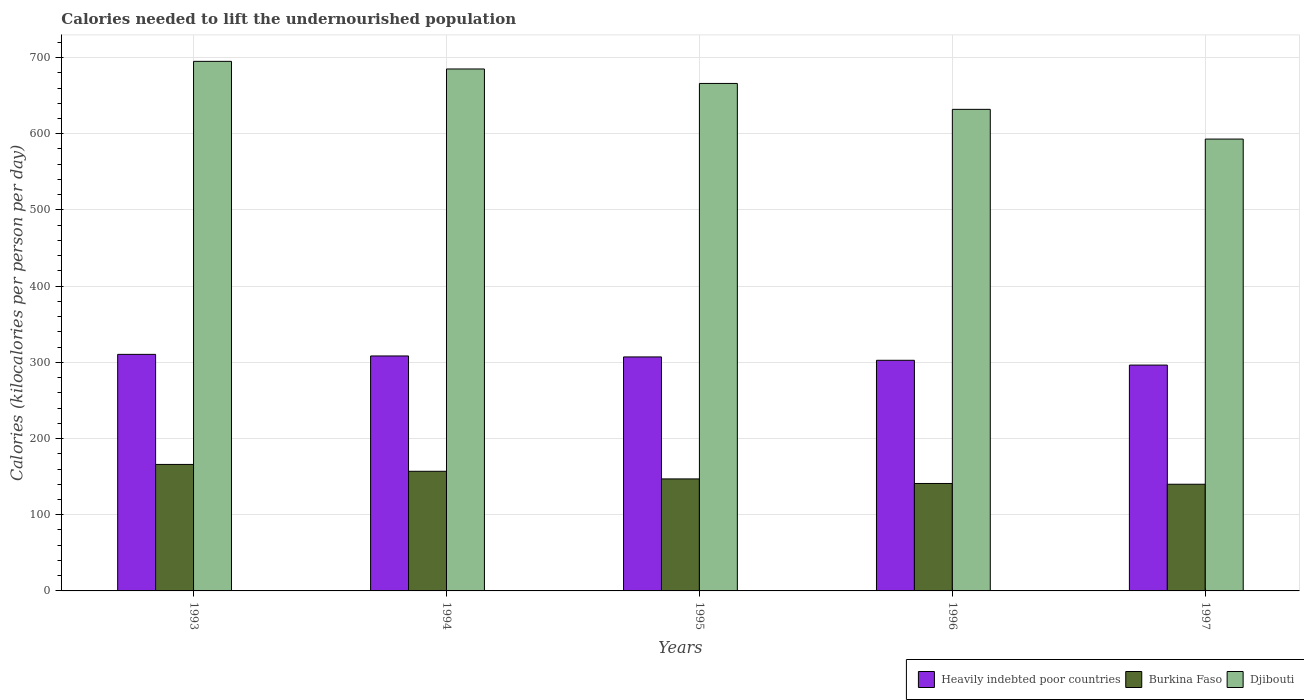How many different coloured bars are there?
Offer a terse response. 3. How many groups of bars are there?
Provide a short and direct response. 5. Are the number of bars per tick equal to the number of legend labels?
Your response must be concise. Yes. Are the number of bars on each tick of the X-axis equal?
Make the answer very short. Yes. How many bars are there on the 4th tick from the left?
Give a very brief answer. 3. How many bars are there on the 1st tick from the right?
Provide a short and direct response. 3. In how many cases, is the number of bars for a given year not equal to the number of legend labels?
Provide a succinct answer. 0. What is the total calories needed to lift the undernourished population in Djibouti in 1996?
Make the answer very short. 632. Across all years, what is the maximum total calories needed to lift the undernourished population in Burkina Faso?
Keep it short and to the point. 166. Across all years, what is the minimum total calories needed to lift the undernourished population in Burkina Faso?
Your answer should be compact. 140. In which year was the total calories needed to lift the undernourished population in Heavily indebted poor countries minimum?
Provide a short and direct response. 1997. What is the total total calories needed to lift the undernourished population in Djibouti in the graph?
Keep it short and to the point. 3271. What is the difference between the total calories needed to lift the undernourished population in Burkina Faso in 1993 and that in 1997?
Offer a terse response. 26. What is the difference between the total calories needed to lift the undernourished population in Burkina Faso in 1997 and the total calories needed to lift the undernourished population in Heavily indebted poor countries in 1994?
Provide a short and direct response. -168.37. What is the average total calories needed to lift the undernourished population in Heavily indebted poor countries per year?
Your response must be concise. 305. In the year 1994, what is the difference between the total calories needed to lift the undernourished population in Djibouti and total calories needed to lift the undernourished population in Heavily indebted poor countries?
Your response must be concise. 376.63. What is the ratio of the total calories needed to lift the undernourished population in Burkina Faso in 1996 to that in 1997?
Offer a very short reply. 1.01. Is the difference between the total calories needed to lift the undernourished population in Djibouti in 1995 and 1997 greater than the difference between the total calories needed to lift the undernourished population in Heavily indebted poor countries in 1995 and 1997?
Keep it short and to the point. Yes. What is the difference between the highest and the second highest total calories needed to lift the undernourished population in Burkina Faso?
Offer a very short reply. 9. What is the difference between the highest and the lowest total calories needed to lift the undernourished population in Burkina Faso?
Offer a very short reply. 26. In how many years, is the total calories needed to lift the undernourished population in Djibouti greater than the average total calories needed to lift the undernourished population in Djibouti taken over all years?
Ensure brevity in your answer.  3. Is the sum of the total calories needed to lift the undernourished population in Djibouti in 1994 and 1997 greater than the maximum total calories needed to lift the undernourished population in Heavily indebted poor countries across all years?
Provide a succinct answer. Yes. What does the 3rd bar from the left in 1996 represents?
Your answer should be compact. Djibouti. What does the 1st bar from the right in 1995 represents?
Provide a short and direct response. Djibouti. Is it the case that in every year, the sum of the total calories needed to lift the undernourished population in Heavily indebted poor countries and total calories needed to lift the undernourished population in Djibouti is greater than the total calories needed to lift the undernourished population in Burkina Faso?
Give a very brief answer. Yes. How many bars are there?
Ensure brevity in your answer.  15. Are all the bars in the graph horizontal?
Keep it short and to the point. No. What is the difference between two consecutive major ticks on the Y-axis?
Provide a short and direct response. 100. What is the title of the graph?
Make the answer very short. Calories needed to lift the undernourished population. What is the label or title of the Y-axis?
Your answer should be compact. Calories (kilocalories per person per day). What is the Calories (kilocalories per person per day) in Heavily indebted poor countries in 1993?
Your response must be concise. 310.45. What is the Calories (kilocalories per person per day) in Burkina Faso in 1993?
Provide a short and direct response. 166. What is the Calories (kilocalories per person per day) in Djibouti in 1993?
Your response must be concise. 695. What is the Calories (kilocalories per person per day) of Heavily indebted poor countries in 1994?
Provide a succinct answer. 308.37. What is the Calories (kilocalories per person per day) of Burkina Faso in 1994?
Your answer should be very brief. 157. What is the Calories (kilocalories per person per day) of Djibouti in 1994?
Provide a short and direct response. 685. What is the Calories (kilocalories per person per day) of Heavily indebted poor countries in 1995?
Provide a succinct answer. 307.09. What is the Calories (kilocalories per person per day) in Burkina Faso in 1995?
Offer a terse response. 147. What is the Calories (kilocalories per person per day) of Djibouti in 1995?
Offer a terse response. 666. What is the Calories (kilocalories per person per day) in Heavily indebted poor countries in 1996?
Make the answer very short. 302.69. What is the Calories (kilocalories per person per day) in Burkina Faso in 1996?
Give a very brief answer. 141. What is the Calories (kilocalories per person per day) in Djibouti in 1996?
Your response must be concise. 632. What is the Calories (kilocalories per person per day) in Heavily indebted poor countries in 1997?
Your answer should be compact. 296.39. What is the Calories (kilocalories per person per day) in Burkina Faso in 1997?
Ensure brevity in your answer.  140. What is the Calories (kilocalories per person per day) of Djibouti in 1997?
Make the answer very short. 593. Across all years, what is the maximum Calories (kilocalories per person per day) of Heavily indebted poor countries?
Your answer should be compact. 310.45. Across all years, what is the maximum Calories (kilocalories per person per day) in Burkina Faso?
Make the answer very short. 166. Across all years, what is the maximum Calories (kilocalories per person per day) of Djibouti?
Your answer should be very brief. 695. Across all years, what is the minimum Calories (kilocalories per person per day) in Heavily indebted poor countries?
Your answer should be very brief. 296.39. Across all years, what is the minimum Calories (kilocalories per person per day) in Burkina Faso?
Make the answer very short. 140. Across all years, what is the minimum Calories (kilocalories per person per day) in Djibouti?
Ensure brevity in your answer.  593. What is the total Calories (kilocalories per person per day) of Heavily indebted poor countries in the graph?
Provide a short and direct response. 1524.99. What is the total Calories (kilocalories per person per day) in Burkina Faso in the graph?
Your answer should be compact. 751. What is the total Calories (kilocalories per person per day) of Djibouti in the graph?
Offer a very short reply. 3271. What is the difference between the Calories (kilocalories per person per day) in Heavily indebted poor countries in 1993 and that in 1994?
Ensure brevity in your answer.  2.08. What is the difference between the Calories (kilocalories per person per day) of Djibouti in 1993 and that in 1994?
Your response must be concise. 10. What is the difference between the Calories (kilocalories per person per day) of Heavily indebted poor countries in 1993 and that in 1995?
Your response must be concise. 3.35. What is the difference between the Calories (kilocalories per person per day) of Djibouti in 1993 and that in 1995?
Give a very brief answer. 29. What is the difference between the Calories (kilocalories per person per day) in Heavily indebted poor countries in 1993 and that in 1996?
Ensure brevity in your answer.  7.76. What is the difference between the Calories (kilocalories per person per day) of Djibouti in 1993 and that in 1996?
Keep it short and to the point. 63. What is the difference between the Calories (kilocalories per person per day) of Heavily indebted poor countries in 1993 and that in 1997?
Provide a succinct answer. 14.05. What is the difference between the Calories (kilocalories per person per day) of Burkina Faso in 1993 and that in 1997?
Make the answer very short. 26. What is the difference between the Calories (kilocalories per person per day) of Djibouti in 1993 and that in 1997?
Make the answer very short. 102. What is the difference between the Calories (kilocalories per person per day) of Heavily indebted poor countries in 1994 and that in 1995?
Offer a terse response. 1.28. What is the difference between the Calories (kilocalories per person per day) of Burkina Faso in 1994 and that in 1995?
Your answer should be very brief. 10. What is the difference between the Calories (kilocalories per person per day) in Heavily indebted poor countries in 1994 and that in 1996?
Make the answer very short. 5.68. What is the difference between the Calories (kilocalories per person per day) of Heavily indebted poor countries in 1994 and that in 1997?
Offer a terse response. 11.98. What is the difference between the Calories (kilocalories per person per day) of Djibouti in 1994 and that in 1997?
Keep it short and to the point. 92. What is the difference between the Calories (kilocalories per person per day) of Heavily indebted poor countries in 1995 and that in 1996?
Offer a very short reply. 4.4. What is the difference between the Calories (kilocalories per person per day) in Djibouti in 1995 and that in 1996?
Your answer should be compact. 34. What is the difference between the Calories (kilocalories per person per day) of Heavily indebted poor countries in 1995 and that in 1997?
Offer a terse response. 10.7. What is the difference between the Calories (kilocalories per person per day) of Djibouti in 1995 and that in 1997?
Your answer should be compact. 73. What is the difference between the Calories (kilocalories per person per day) in Heavily indebted poor countries in 1996 and that in 1997?
Make the answer very short. 6.3. What is the difference between the Calories (kilocalories per person per day) in Burkina Faso in 1996 and that in 1997?
Make the answer very short. 1. What is the difference between the Calories (kilocalories per person per day) of Djibouti in 1996 and that in 1997?
Offer a very short reply. 39. What is the difference between the Calories (kilocalories per person per day) in Heavily indebted poor countries in 1993 and the Calories (kilocalories per person per day) in Burkina Faso in 1994?
Your answer should be very brief. 153.45. What is the difference between the Calories (kilocalories per person per day) in Heavily indebted poor countries in 1993 and the Calories (kilocalories per person per day) in Djibouti in 1994?
Give a very brief answer. -374.55. What is the difference between the Calories (kilocalories per person per day) in Burkina Faso in 1993 and the Calories (kilocalories per person per day) in Djibouti in 1994?
Make the answer very short. -519. What is the difference between the Calories (kilocalories per person per day) of Heavily indebted poor countries in 1993 and the Calories (kilocalories per person per day) of Burkina Faso in 1995?
Make the answer very short. 163.45. What is the difference between the Calories (kilocalories per person per day) of Heavily indebted poor countries in 1993 and the Calories (kilocalories per person per day) of Djibouti in 1995?
Provide a succinct answer. -355.55. What is the difference between the Calories (kilocalories per person per day) in Burkina Faso in 1993 and the Calories (kilocalories per person per day) in Djibouti in 1995?
Your answer should be compact. -500. What is the difference between the Calories (kilocalories per person per day) of Heavily indebted poor countries in 1993 and the Calories (kilocalories per person per day) of Burkina Faso in 1996?
Provide a succinct answer. 169.45. What is the difference between the Calories (kilocalories per person per day) in Heavily indebted poor countries in 1993 and the Calories (kilocalories per person per day) in Djibouti in 1996?
Your response must be concise. -321.55. What is the difference between the Calories (kilocalories per person per day) of Burkina Faso in 1993 and the Calories (kilocalories per person per day) of Djibouti in 1996?
Offer a terse response. -466. What is the difference between the Calories (kilocalories per person per day) in Heavily indebted poor countries in 1993 and the Calories (kilocalories per person per day) in Burkina Faso in 1997?
Your response must be concise. 170.45. What is the difference between the Calories (kilocalories per person per day) of Heavily indebted poor countries in 1993 and the Calories (kilocalories per person per day) of Djibouti in 1997?
Make the answer very short. -282.55. What is the difference between the Calories (kilocalories per person per day) of Burkina Faso in 1993 and the Calories (kilocalories per person per day) of Djibouti in 1997?
Offer a very short reply. -427. What is the difference between the Calories (kilocalories per person per day) in Heavily indebted poor countries in 1994 and the Calories (kilocalories per person per day) in Burkina Faso in 1995?
Provide a succinct answer. 161.37. What is the difference between the Calories (kilocalories per person per day) of Heavily indebted poor countries in 1994 and the Calories (kilocalories per person per day) of Djibouti in 1995?
Ensure brevity in your answer.  -357.63. What is the difference between the Calories (kilocalories per person per day) of Burkina Faso in 1994 and the Calories (kilocalories per person per day) of Djibouti in 1995?
Offer a very short reply. -509. What is the difference between the Calories (kilocalories per person per day) in Heavily indebted poor countries in 1994 and the Calories (kilocalories per person per day) in Burkina Faso in 1996?
Provide a short and direct response. 167.37. What is the difference between the Calories (kilocalories per person per day) in Heavily indebted poor countries in 1994 and the Calories (kilocalories per person per day) in Djibouti in 1996?
Your answer should be very brief. -323.63. What is the difference between the Calories (kilocalories per person per day) in Burkina Faso in 1994 and the Calories (kilocalories per person per day) in Djibouti in 1996?
Give a very brief answer. -475. What is the difference between the Calories (kilocalories per person per day) of Heavily indebted poor countries in 1994 and the Calories (kilocalories per person per day) of Burkina Faso in 1997?
Your response must be concise. 168.37. What is the difference between the Calories (kilocalories per person per day) of Heavily indebted poor countries in 1994 and the Calories (kilocalories per person per day) of Djibouti in 1997?
Offer a terse response. -284.63. What is the difference between the Calories (kilocalories per person per day) in Burkina Faso in 1994 and the Calories (kilocalories per person per day) in Djibouti in 1997?
Your response must be concise. -436. What is the difference between the Calories (kilocalories per person per day) in Heavily indebted poor countries in 1995 and the Calories (kilocalories per person per day) in Burkina Faso in 1996?
Ensure brevity in your answer.  166.09. What is the difference between the Calories (kilocalories per person per day) in Heavily indebted poor countries in 1995 and the Calories (kilocalories per person per day) in Djibouti in 1996?
Make the answer very short. -324.91. What is the difference between the Calories (kilocalories per person per day) of Burkina Faso in 1995 and the Calories (kilocalories per person per day) of Djibouti in 1996?
Provide a short and direct response. -485. What is the difference between the Calories (kilocalories per person per day) of Heavily indebted poor countries in 1995 and the Calories (kilocalories per person per day) of Burkina Faso in 1997?
Your answer should be very brief. 167.09. What is the difference between the Calories (kilocalories per person per day) in Heavily indebted poor countries in 1995 and the Calories (kilocalories per person per day) in Djibouti in 1997?
Offer a very short reply. -285.91. What is the difference between the Calories (kilocalories per person per day) in Burkina Faso in 1995 and the Calories (kilocalories per person per day) in Djibouti in 1997?
Provide a short and direct response. -446. What is the difference between the Calories (kilocalories per person per day) of Heavily indebted poor countries in 1996 and the Calories (kilocalories per person per day) of Burkina Faso in 1997?
Make the answer very short. 162.69. What is the difference between the Calories (kilocalories per person per day) in Heavily indebted poor countries in 1996 and the Calories (kilocalories per person per day) in Djibouti in 1997?
Provide a succinct answer. -290.31. What is the difference between the Calories (kilocalories per person per day) of Burkina Faso in 1996 and the Calories (kilocalories per person per day) of Djibouti in 1997?
Offer a very short reply. -452. What is the average Calories (kilocalories per person per day) of Heavily indebted poor countries per year?
Offer a terse response. 305. What is the average Calories (kilocalories per person per day) of Burkina Faso per year?
Keep it short and to the point. 150.2. What is the average Calories (kilocalories per person per day) in Djibouti per year?
Your response must be concise. 654.2. In the year 1993, what is the difference between the Calories (kilocalories per person per day) of Heavily indebted poor countries and Calories (kilocalories per person per day) of Burkina Faso?
Provide a short and direct response. 144.45. In the year 1993, what is the difference between the Calories (kilocalories per person per day) of Heavily indebted poor countries and Calories (kilocalories per person per day) of Djibouti?
Your answer should be compact. -384.55. In the year 1993, what is the difference between the Calories (kilocalories per person per day) in Burkina Faso and Calories (kilocalories per person per day) in Djibouti?
Provide a short and direct response. -529. In the year 1994, what is the difference between the Calories (kilocalories per person per day) of Heavily indebted poor countries and Calories (kilocalories per person per day) of Burkina Faso?
Your answer should be very brief. 151.37. In the year 1994, what is the difference between the Calories (kilocalories per person per day) in Heavily indebted poor countries and Calories (kilocalories per person per day) in Djibouti?
Your response must be concise. -376.63. In the year 1994, what is the difference between the Calories (kilocalories per person per day) of Burkina Faso and Calories (kilocalories per person per day) of Djibouti?
Give a very brief answer. -528. In the year 1995, what is the difference between the Calories (kilocalories per person per day) of Heavily indebted poor countries and Calories (kilocalories per person per day) of Burkina Faso?
Provide a short and direct response. 160.09. In the year 1995, what is the difference between the Calories (kilocalories per person per day) in Heavily indebted poor countries and Calories (kilocalories per person per day) in Djibouti?
Provide a succinct answer. -358.91. In the year 1995, what is the difference between the Calories (kilocalories per person per day) in Burkina Faso and Calories (kilocalories per person per day) in Djibouti?
Offer a terse response. -519. In the year 1996, what is the difference between the Calories (kilocalories per person per day) of Heavily indebted poor countries and Calories (kilocalories per person per day) of Burkina Faso?
Make the answer very short. 161.69. In the year 1996, what is the difference between the Calories (kilocalories per person per day) of Heavily indebted poor countries and Calories (kilocalories per person per day) of Djibouti?
Provide a short and direct response. -329.31. In the year 1996, what is the difference between the Calories (kilocalories per person per day) of Burkina Faso and Calories (kilocalories per person per day) of Djibouti?
Give a very brief answer. -491. In the year 1997, what is the difference between the Calories (kilocalories per person per day) of Heavily indebted poor countries and Calories (kilocalories per person per day) of Burkina Faso?
Ensure brevity in your answer.  156.39. In the year 1997, what is the difference between the Calories (kilocalories per person per day) of Heavily indebted poor countries and Calories (kilocalories per person per day) of Djibouti?
Your response must be concise. -296.61. In the year 1997, what is the difference between the Calories (kilocalories per person per day) of Burkina Faso and Calories (kilocalories per person per day) of Djibouti?
Ensure brevity in your answer.  -453. What is the ratio of the Calories (kilocalories per person per day) of Burkina Faso in 1993 to that in 1994?
Offer a terse response. 1.06. What is the ratio of the Calories (kilocalories per person per day) of Djibouti in 1993 to that in 1994?
Keep it short and to the point. 1.01. What is the ratio of the Calories (kilocalories per person per day) of Heavily indebted poor countries in 1993 to that in 1995?
Offer a terse response. 1.01. What is the ratio of the Calories (kilocalories per person per day) in Burkina Faso in 1993 to that in 1995?
Offer a very short reply. 1.13. What is the ratio of the Calories (kilocalories per person per day) of Djibouti in 1993 to that in 1995?
Your answer should be compact. 1.04. What is the ratio of the Calories (kilocalories per person per day) of Heavily indebted poor countries in 1993 to that in 1996?
Provide a short and direct response. 1.03. What is the ratio of the Calories (kilocalories per person per day) of Burkina Faso in 1993 to that in 1996?
Keep it short and to the point. 1.18. What is the ratio of the Calories (kilocalories per person per day) in Djibouti in 1993 to that in 1996?
Keep it short and to the point. 1.1. What is the ratio of the Calories (kilocalories per person per day) of Heavily indebted poor countries in 1993 to that in 1997?
Provide a succinct answer. 1.05. What is the ratio of the Calories (kilocalories per person per day) in Burkina Faso in 1993 to that in 1997?
Make the answer very short. 1.19. What is the ratio of the Calories (kilocalories per person per day) of Djibouti in 1993 to that in 1997?
Your response must be concise. 1.17. What is the ratio of the Calories (kilocalories per person per day) in Heavily indebted poor countries in 1994 to that in 1995?
Your response must be concise. 1. What is the ratio of the Calories (kilocalories per person per day) in Burkina Faso in 1994 to that in 1995?
Provide a short and direct response. 1.07. What is the ratio of the Calories (kilocalories per person per day) in Djibouti in 1994 to that in 1995?
Make the answer very short. 1.03. What is the ratio of the Calories (kilocalories per person per day) of Heavily indebted poor countries in 1994 to that in 1996?
Provide a short and direct response. 1.02. What is the ratio of the Calories (kilocalories per person per day) in Burkina Faso in 1994 to that in 1996?
Ensure brevity in your answer.  1.11. What is the ratio of the Calories (kilocalories per person per day) in Djibouti in 1994 to that in 1996?
Your answer should be compact. 1.08. What is the ratio of the Calories (kilocalories per person per day) of Heavily indebted poor countries in 1994 to that in 1997?
Your response must be concise. 1.04. What is the ratio of the Calories (kilocalories per person per day) of Burkina Faso in 1994 to that in 1997?
Your answer should be very brief. 1.12. What is the ratio of the Calories (kilocalories per person per day) of Djibouti in 1994 to that in 1997?
Offer a very short reply. 1.16. What is the ratio of the Calories (kilocalories per person per day) in Heavily indebted poor countries in 1995 to that in 1996?
Ensure brevity in your answer.  1.01. What is the ratio of the Calories (kilocalories per person per day) in Burkina Faso in 1995 to that in 1996?
Your answer should be compact. 1.04. What is the ratio of the Calories (kilocalories per person per day) in Djibouti in 1995 to that in 1996?
Offer a very short reply. 1.05. What is the ratio of the Calories (kilocalories per person per day) of Heavily indebted poor countries in 1995 to that in 1997?
Your answer should be very brief. 1.04. What is the ratio of the Calories (kilocalories per person per day) of Burkina Faso in 1995 to that in 1997?
Provide a succinct answer. 1.05. What is the ratio of the Calories (kilocalories per person per day) of Djibouti in 1995 to that in 1997?
Your answer should be compact. 1.12. What is the ratio of the Calories (kilocalories per person per day) of Heavily indebted poor countries in 1996 to that in 1997?
Keep it short and to the point. 1.02. What is the ratio of the Calories (kilocalories per person per day) in Burkina Faso in 1996 to that in 1997?
Your answer should be compact. 1.01. What is the ratio of the Calories (kilocalories per person per day) of Djibouti in 1996 to that in 1997?
Your response must be concise. 1.07. What is the difference between the highest and the second highest Calories (kilocalories per person per day) of Heavily indebted poor countries?
Provide a short and direct response. 2.08. What is the difference between the highest and the lowest Calories (kilocalories per person per day) of Heavily indebted poor countries?
Your answer should be very brief. 14.05. What is the difference between the highest and the lowest Calories (kilocalories per person per day) of Burkina Faso?
Make the answer very short. 26. What is the difference between the highest and the lowest Calories (kilocalories per person per day) in Djibouti?
Provide a succinct answer. 102. 